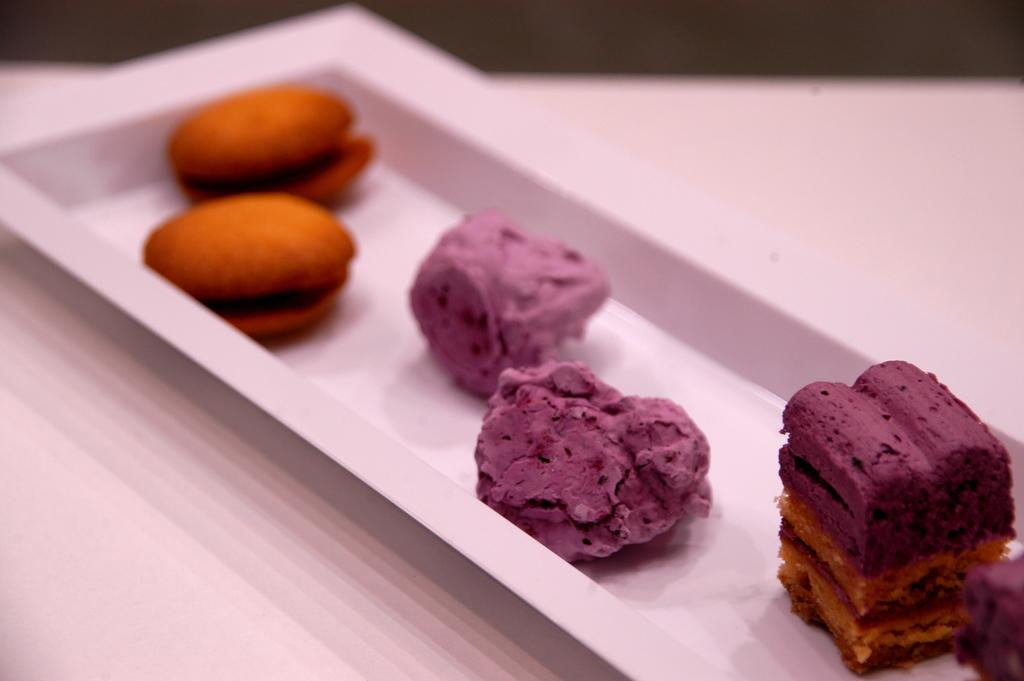What type of furniture is present in the image? There is a table in the image. What is placed on the table? There is a plate on the table. What is on the plate? There is a food item on the plate. What type of nail can be seen in the image? There is no nail present in the image. What type of clouds can be seen in the image? There are no clouds present in the image. What type of dirt can be seen on the table in the image? There is no dirt present on the table in the image. 